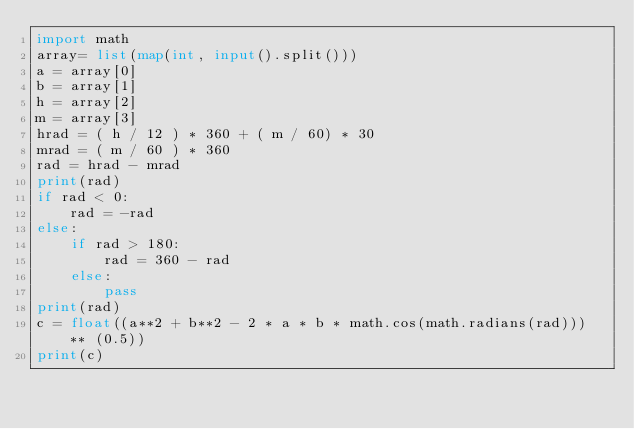Convert code to text. <code><loc_0><loc_0><loc_500><loc_500><_Python_>import math
array= list(map(int, input().split()))
a = array[0]
b = array[1]
h = array[2]
m = array[3]
hrad = ( h / 12 ) * 360 + ( m / 60) * 30
mrad = ( m / 60 ) * 360
rad = hrad - mrad
print(rad)
if rad < 0:
    rad = -rad
else:
    if rad > 180:
        rad = 360 - rad
    else:
        pass
print(rad)
c = float((a**2 + b**2 - 2 * a * b * math.cos(math.radians(rad))) ** (0.5))
print(c)
</code> 